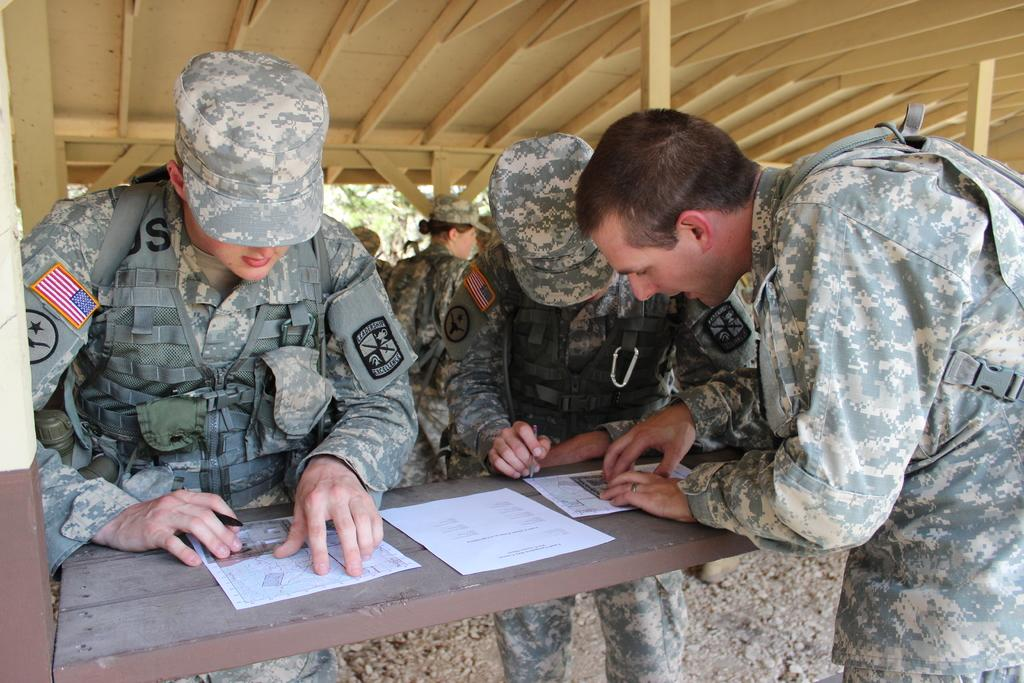What are the people in the image wearing? The people in the image are wearing army clothes. What is on the table in the image? There are papers, a pen, a stand, and a pole on the table in the image. What is the cap used for in the image? The cap is likely used for covering or protecting the head of the person wearing it. What can be seen in the background of the image? There are trees visible in the background of the image. What religion is being practiced by the people in the image? There is no indication of any religious practice in the image; the people are wearing army clothes. How many hands are visible in the image? The number of hands visible in the image cannot be determined from the provided facts. 